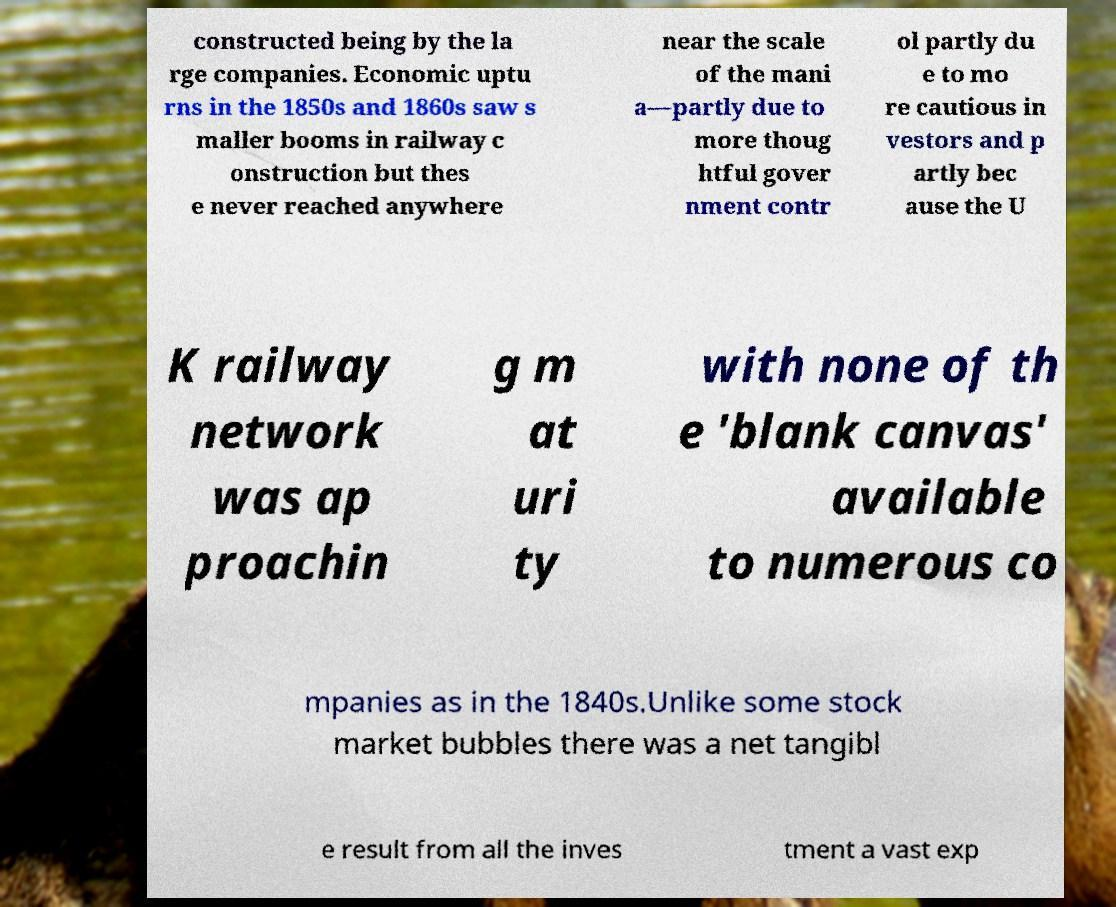Could you extract and type out the text from this image? constructed being by the la rge companies. Economic uptu rns in the 1850s and 1860s saw s maller booms in railway c onstruction but thes e never reached anywhere near the scale of the mani a—partly due to more thoug htful gover nment contr ol partly du e to mo re cautious in vestors and p artly bec ause the U K railway network was ap proachin g m at uri ty with none of th e 'blank canvas' available to numerous co mpanies as in the 1840s.Unlike some stock market bubbles there was a net tangibl e result from all the inves tment a vast exp 